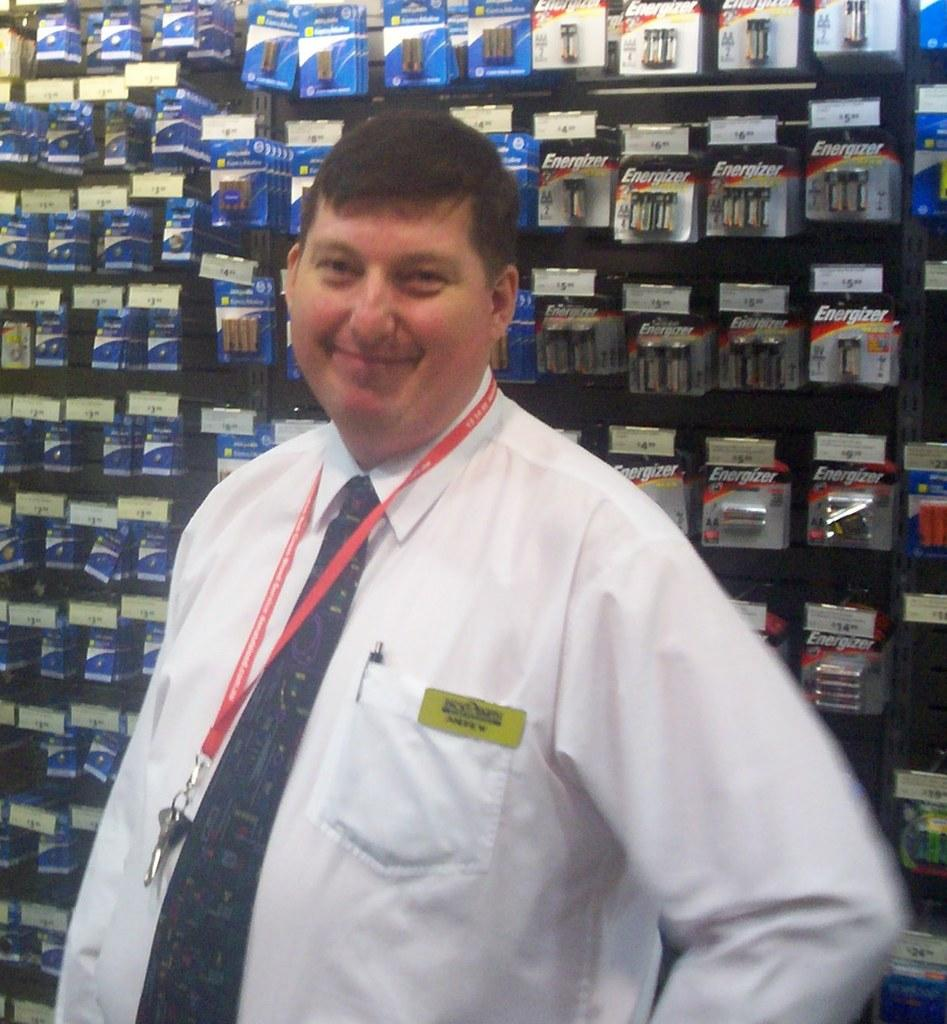Provide a one-sentence caption for the provided image. man with nametag Andrew standing in front of wall of batteries including energizer brand. 